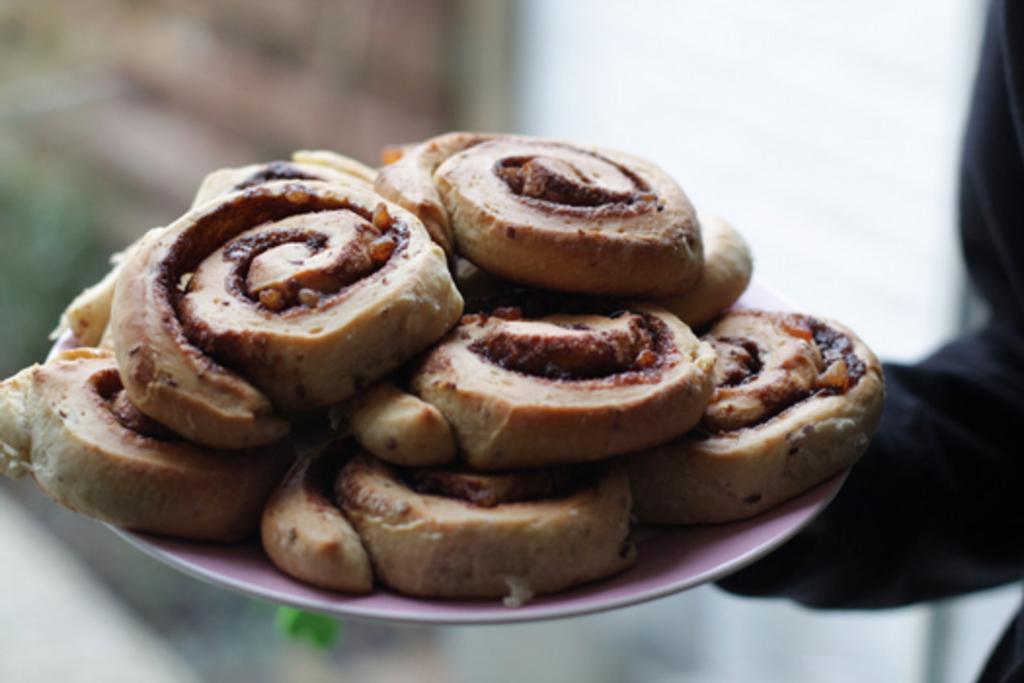How would you summarize this image in a sentence or two? In this image I can see few food items in the plate and the food items are in brown color and I can see the blurred background. 